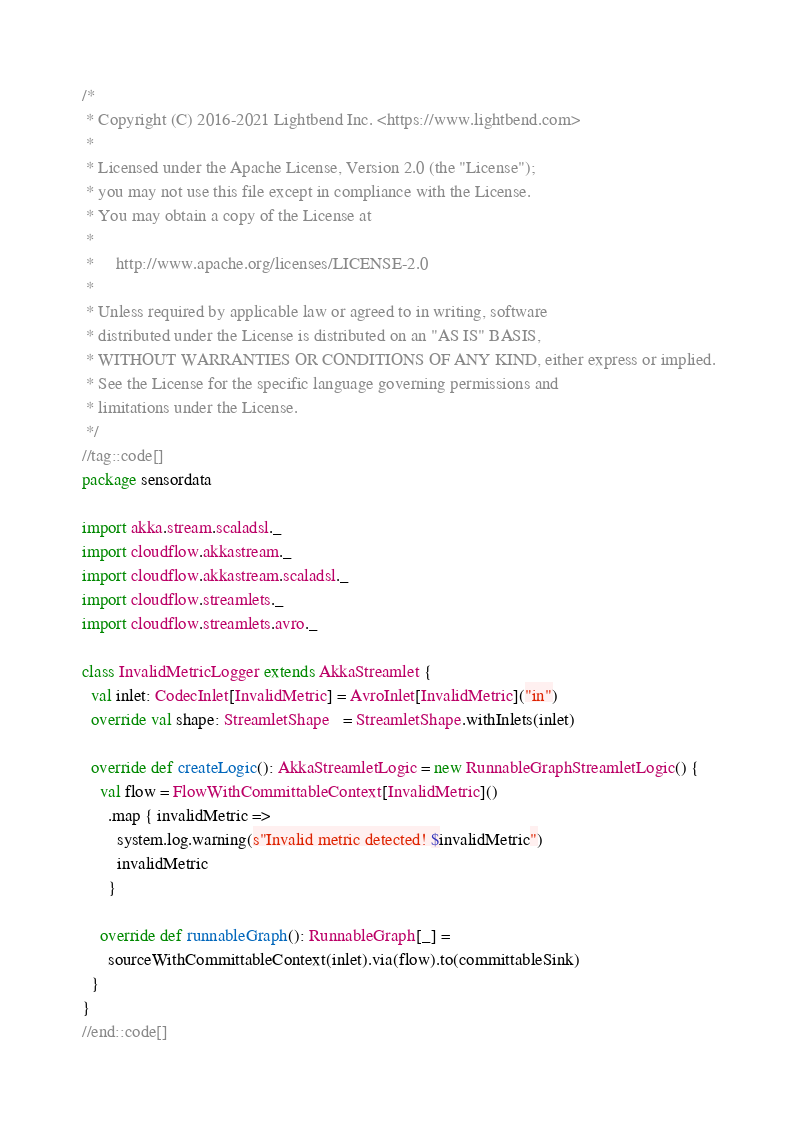<code> <loc_0><loc_0><loc_500><loc_500><_Scala_>/*
 * Copyright (C) 2016-2021 Lightbend Inc. <https://www.lightbend.com>
 *
 * Licensed under the Apache License, Version 2.0 (the "License");
 * you may not use this file except in compliance with the License.
 * You may obtain a copy of the License at
 *
 *     http://www.apache.org/licenses/LICENSE-2.0
 *
 * Unless required by applicable law or agreed to in writing, software
 * distributed under the License is distributed on an "AS IS" BASIS,
 * WITHOUT WARRANTIES OR CONDITIONS OF ANY KIND, either express or implied.
 * See the License for the specific language governing permissions and
 * limitations under the License.
 */
//tag::code[]
package sensordata

import akka.stream.scaladsl._
import cloudflow.akkastream._
import cloudflow.akkastream.scaladsl._
import cloudflow.streamlets._
import cloudflow.streamlets.avro._

class InvalidMetricLogger extends AkkaStreamlet {
  val inlet: CodecInlet[InvalidMetric] = AvroInlet[InvalidMetric]("in")
  override val shape: StreamletShape   = StreamletShape.withInlets(inlet)

  override def createLogic(): AkkaStreamletLogic = new RunnableGraphStreamletLogic() {
    val flow = FlowWithCommittableContext[InvalidMetric]()
      .map { invalidMetric =>
        system.log.warning(s"Invalid metric detected! $invalidMetric")
        invalidMetric
      }

    override def runnableGraph(): RunnableGraph[_] =
      sourceWithCommittableContext(inlet).via(flow).to(committableSink)
  }
}
//end::code[]
</code> 